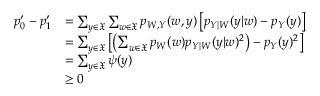<formula> <loc_0><loc_0><loc_500><loc_500>\begin{array} { r l } { p _ { 0 } ^ { \prime } - p _ { 1 } ^ { \prime } } & { = \sum _ { y \in \mathfrak { X } } \sum _ { w \in \mathfrak { X } } p _ { W , Y } ( w , y ) \left [ p _ { Y | W } ( y | w ) - p _ { Y } ( y ) \right ] } \\ & { = \sum _ { y \in \mathfrak { X } } \left [ \left ( \sum _ { w \in \mathfrak { X } } p _ { W } ( w ) p _ { Y | W } ( y | w ) ^ { 2 } \right ) - p _ { Y } ( y ) ^ { 2 } \right ] } \\ & { = \sum _ { y \in \mathfrak { X } } \psi ( y ) } \\ & { \geq 0 } \end{array}</formula> 